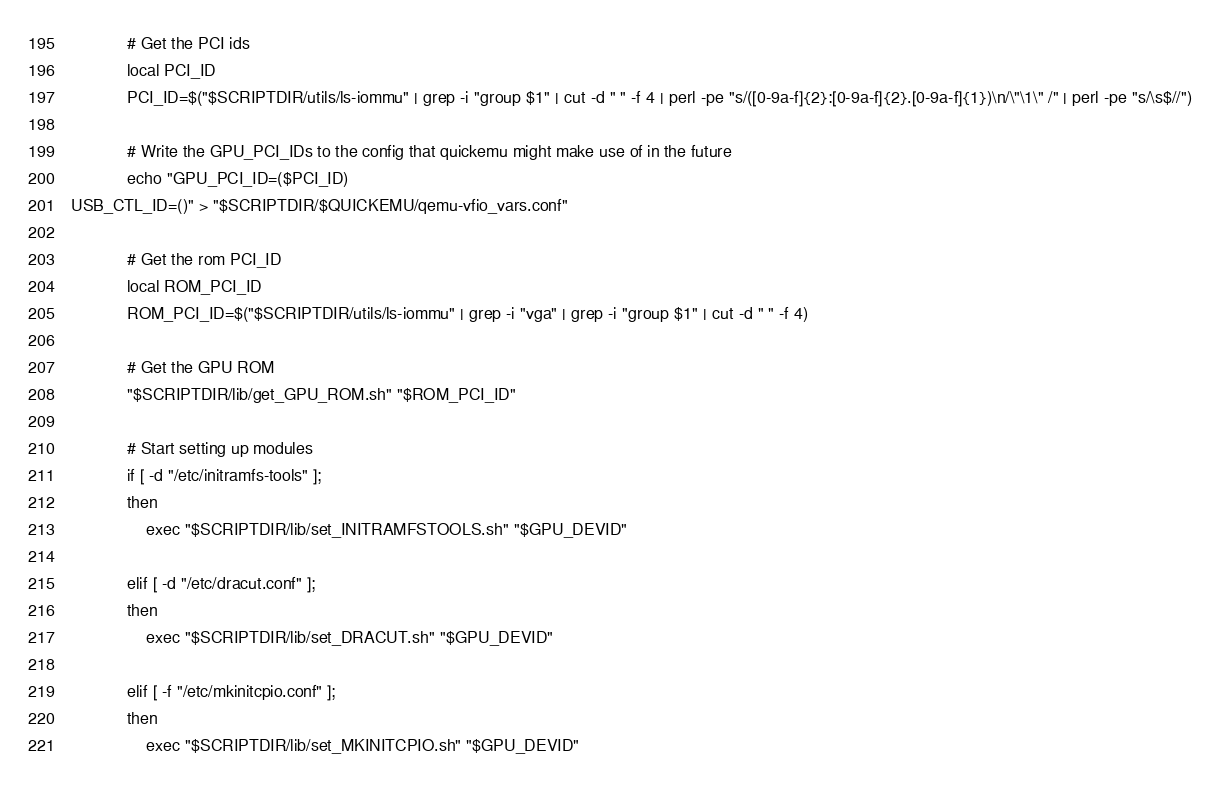<code> <loc_0><loc_0><loc_500><loc_500><_Bash_>
            # Get the PCI ids
            local PCI_ID
            PCI_ID=$("$SCRIPTDIR/utils/ls-iommu" | grep -i "group $1" | cut -d " " -f 4 | perl -pe "s/([0-9a-f]{2}:[0-9a-f]{2}.[0-9a-f]{1})\n/\"\1\" /" | perl -pe "s/\s$//")

            # Write the GPU_PCI_IDs to the config that quickemu might make use of in the future
            echo "GPU_PCI_ID=($PCI_ID)
USB_CTL_ID=()" > "$SCRIPTDIR/$QUICKEMU/qemu-vfio_vars.conf"

            # Get the rom PCI_ID
            local ROM_PCI_ID
            ROM_PCI_ID=$("$SCRIPTDIR/utils/ls-iommu" | grep -i "vga" | grep -i "group $1" | cut -d " " -f 4)

            # Get the GPU ROM
            "$SCRIPTDIR/lib/get_GPU_ROM.sh" "$ROM_PCI_ID"

            # Start setting up modules
            if [ -d "/etc/initramfs-tools" ];
            then
                exec "$SCRIPTDIR/lib/set_INITRAMFSTOOLS.sh" "$GPU_DEVID"
            
            elif [ -d "/etc/dracut.conf" ];
            then
                exec "$SCRIPTDIR/lib/set_DRACUT.sh" "$GPU_DEVID"
            
            elif [ -f "/etc/mkinitcpio.conf" ];
            then
                exec "$SCRIPTDIR/lib/set_MKINITCPIO.sh" "$GPU_DEVID"</code> 